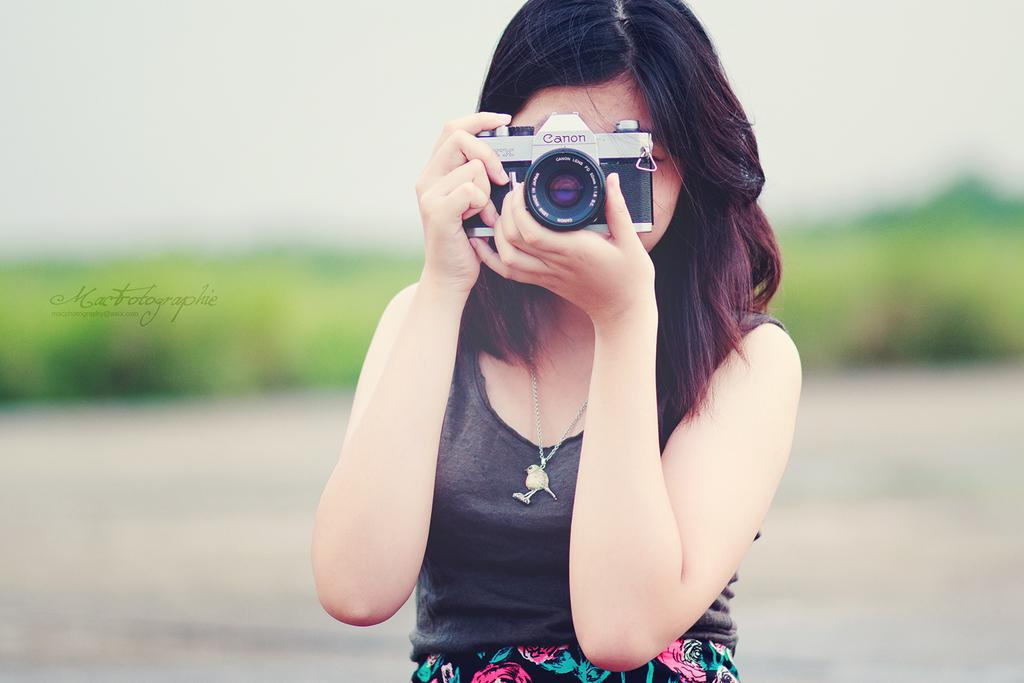Who is the main subject in the image? There is a woman in the image. What is the woman doing in the image? The woman is holding a camera in front of her face. What is the woman wearing in the image? The woman is wearing a black dress and an ornament. What can be seen in the background of the image? There are plants in the background of the image. What type of muscle is the woman exercising in the image? There is no indication of the woman exercising or using any muscles in the image; she is holding a camera in front of her face. 